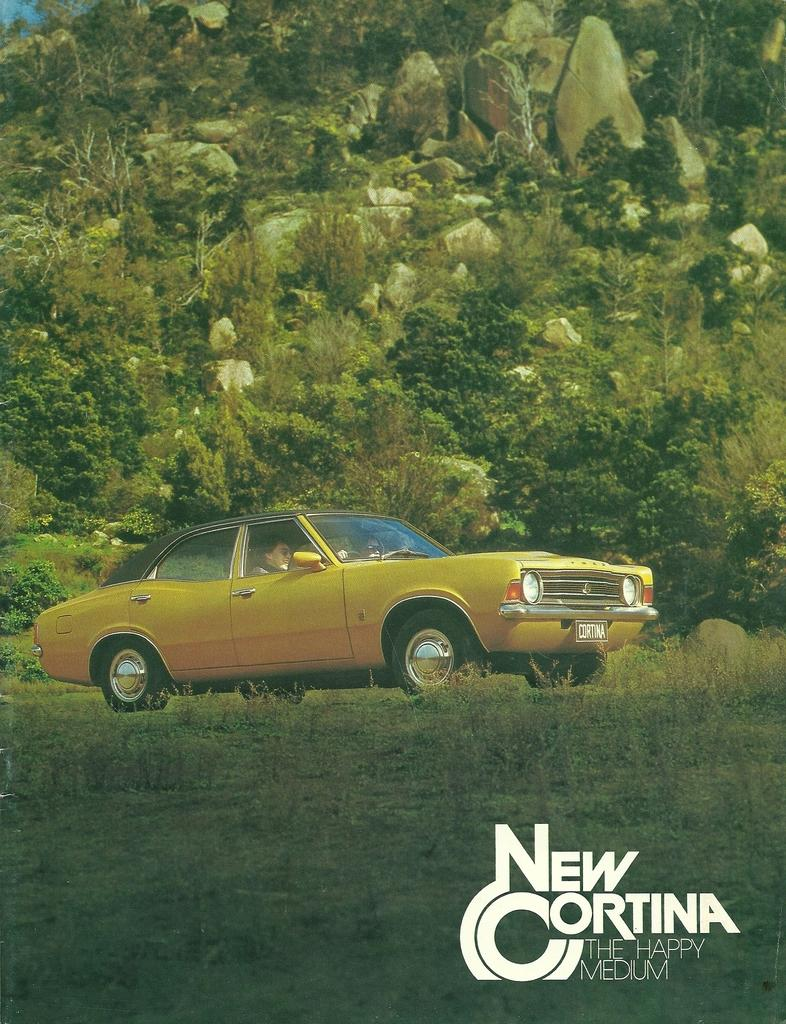What is the person in the image doing? The person is sitting in a car. Where is the car located in the image? The car is parked on the ground. What can be seen in the background of the image? There is a group of cars and stones in the background. What is written or displayed at the bottom of the image? There is some text at the bottom of the image. What type of sock is the person wearing in the image? There is no sock visible in the image, as the person is sitting in a car and their feet are not shown. 